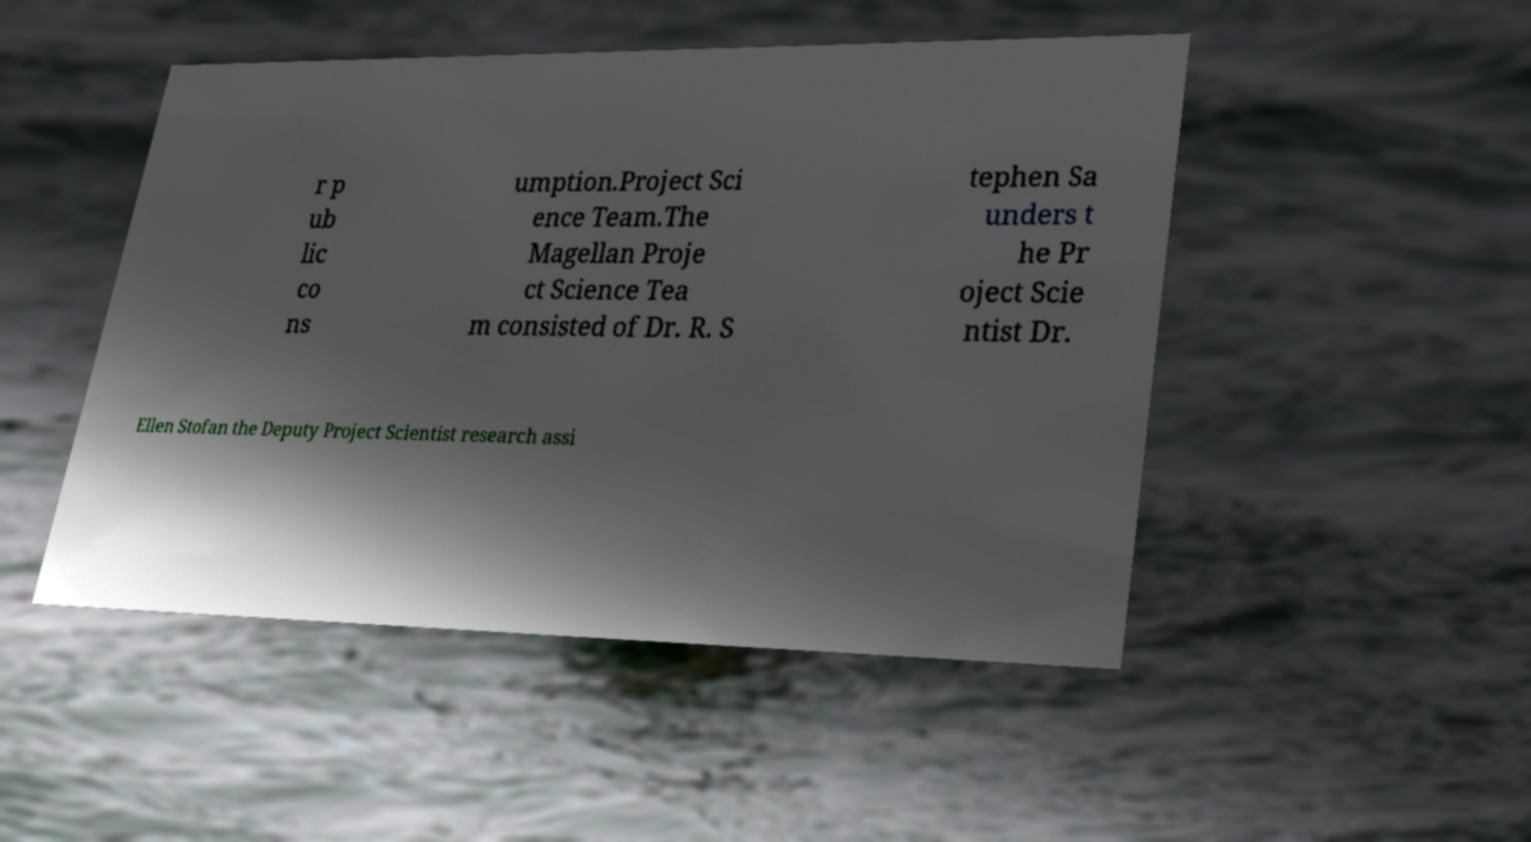For documentation purposes, I need the text within this image transcribed. Could you provide that? r p ub lic co ns umption.Project Sci ence Team.The Magellan Proje ct Science Tea m consisted of Dr. R. S tephen Sa unders t he Pr oject Scie ntist Dr. Ellen Stofan the Deputy Project Scientist research assi 